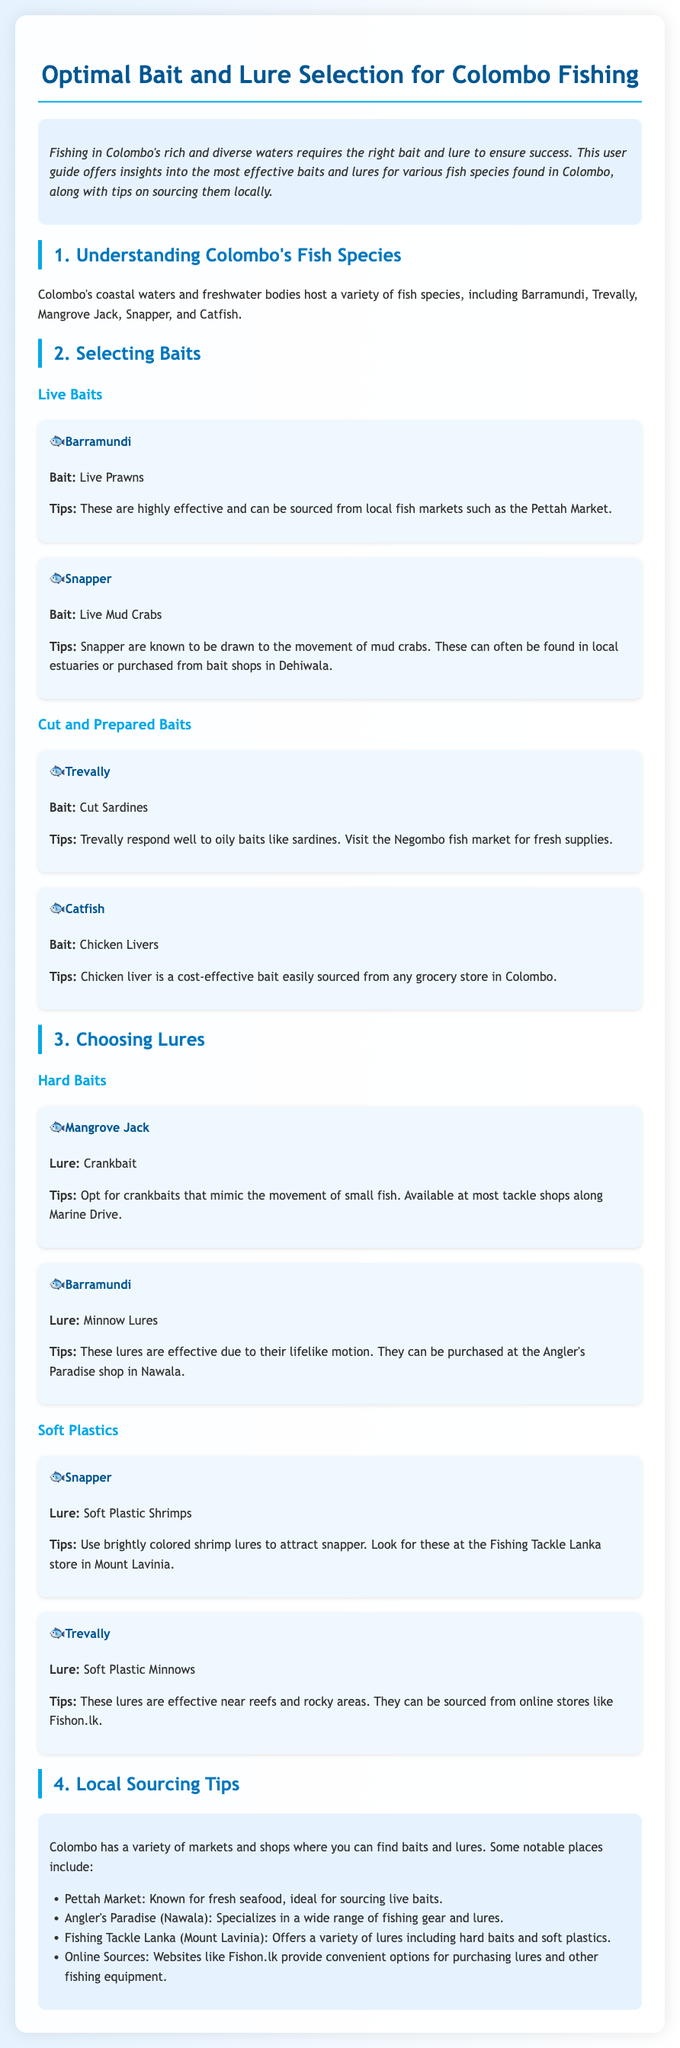What bait is recommended for Barramundi? The document states that live prawns are recommended as bait for Barramundi.
Answer: Live Prawns Where can you source live mud crabs for Snapper? The document mentions that live mud crabs can often be found in local estuaries or purchased from bait shops in Dehiwala.
Answer: Bait shops in Dehiwala What type of lure is effective for Mangrove Jack? The guide specifies that crankbaits are effective lures for Mangrove Jack.
Answer: Crankbait Which market is known for fresh seafood in Colombo? Pettah Market is described as known for fresh seafood, ideal for sourcing live baits.
Answer: Pettah Market What type of bait is suggested for Trevally? The document indicates that cut sardines are suggested as bait for Trevally.
Answer: Cut Sardines Which store in Mount Lavinia offers soft plastic shrimp lures? The guide indicates that Fishing Tackle Lanka in Mount Lavinia offers a variety of lures including soft plastic shrimp lures.
Answer: Fishing Tackle Lanka What is a cost-effective bait for Catfish? The document states that chicken livers are a cost-effective bait for Catfish.
Answer: Chicken Livers Where can you purchase minnows for Barramundi? The Angler's Paradise shop in Nawala is mentioned as a place to purchase minnows for Barramundi.
Answer: Angler's Paradise (Nawala) What type of lures can be found at Fishon.lk? The document mentions that Fishon.lk provides convenient options for purchasing lures and other fishing equipment.
Answer: Lures 